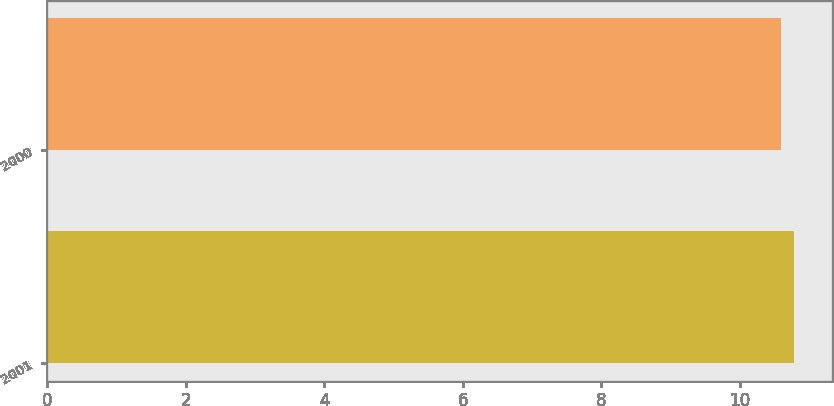<chart> <loc_0><loc_0><loc_500><loc_500><bar_chart><fcel>2001<fcel>2000<nl><fcel>10.79<fcel>10.59<nl></chart> 